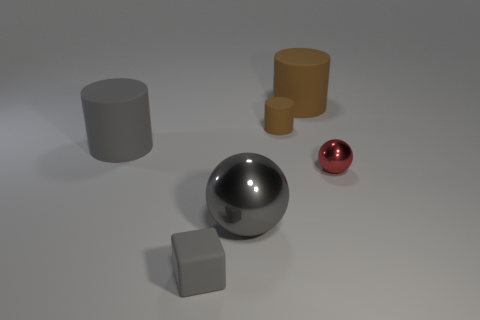Subtract all tiny matte cylinders. How many cylinders are left? 2 Subtract all gray balls. How many balls are left? 1 Subtract 1 cylinders. How many cylinders are left? 2 Add 1 tiny blue rubber things. How many objects exist? 7 Subtract all blocks. How many objects are left? 5 Add 5 large brown matte things. How many large brown matte things are left? 6 Add 4 small red cylinders. How many small red cylinders exist? 4 Subtract 0 cyan cubes. How many objects are left? 6 Subtract all cyan cylinders. Subtract all purple blocks. How many cylinders are left? 3 Subtract all purple spheres. How many yellow cylinders are left? 0 